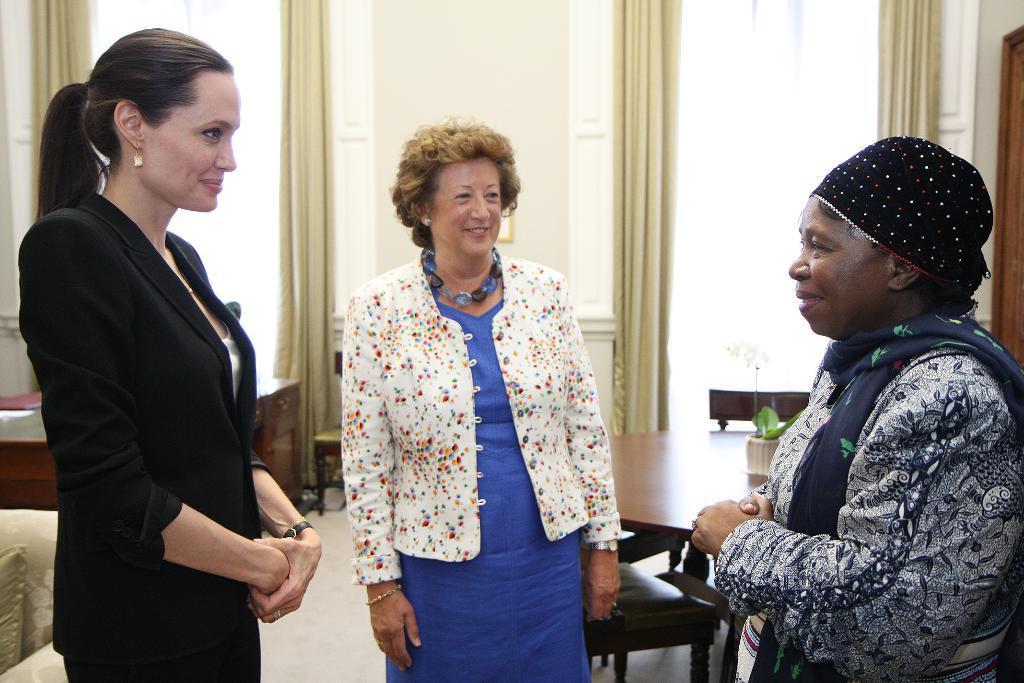Can you describe this image briefly? in this picture the right side woman is standing on the floor and on the right side the woman is standing the floor she is wearing black dress in the middle another woman is standing on the floor all of them are laughing each other behind the women there are table,chairs and windows the background is white 